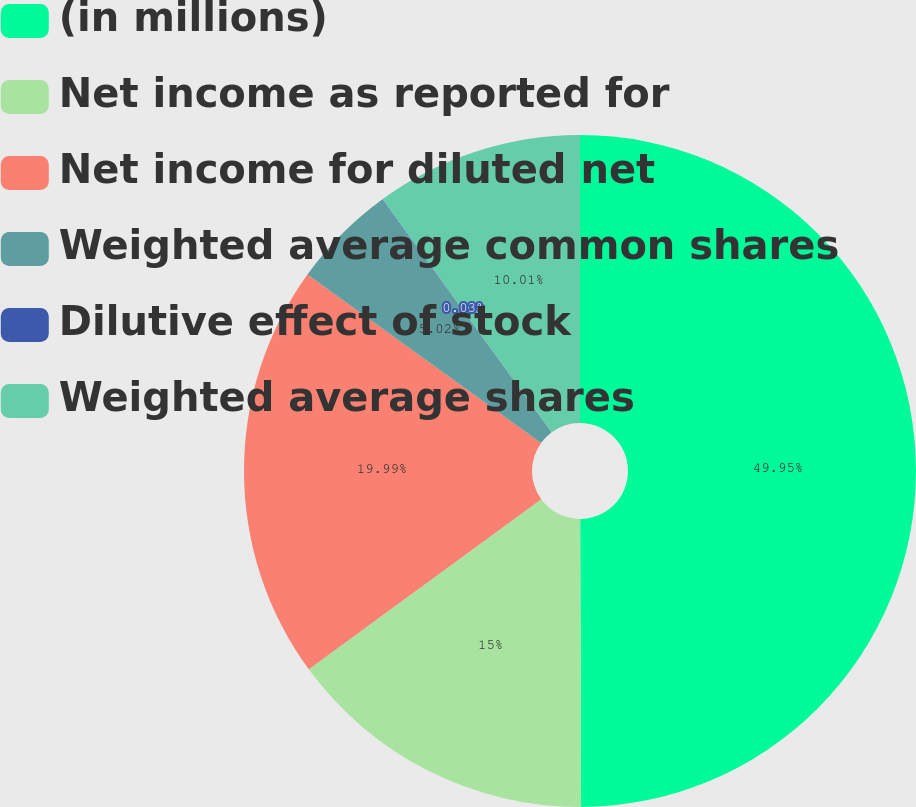Convert chart to OTSL. <chart><loc_0><loc_0><loc_500><loc_500><pie_chart><fcel>(in millions)<fcel>Net income as reported for<fcel>Net income for diluted net<fcel>Weighted average common shares<fcel>Dilutive effect of stock<fcel>Weighted average shares<nl><fcel>49.95%<fcel>15.0%<fcel>19.99%<fcel>5.02%<fcel>0.03%<fcel>10.01%<nl></chart> 